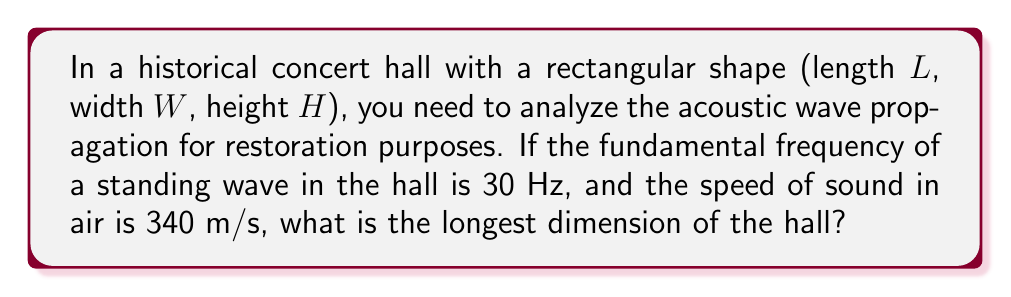Solve this math problem. To solve this problem, we'll follow these steps:

1) The fundamental frequency of a standing wave in a rectangular room is given by:

   $$f = \frac{c}{2} \sqrt{\left(\frac{n_x}{L}\right)^2 + \left(\frac{n_y}{W}\right)^2 + \left(\frac{n_z}{H}\right)^2}$$

   where $c$ is the speed of sound, and $n_x$, $n_y$, and $n_z$ are integers.

2) For the fundamental frequency, $n_x = 1$, $n_y = 0$, and $n_z = 0$ (assuming $L$ is the longest dimension).

3) Substituting these values:

   $$30 = \frac{340}{2} \sqrt{\left(\frac{1}{L}\right)^2 + 0 + 0}$$

4) Simplify:

   $$30 = \frac{340}{2L}$$

5) Solve for $L$:

   $$L = \frac{340}{2 \cdot 30} = \frac{340}{60} = \frac{17}{3} \approx 5.67$$

Therefore, the longest dimension of the hall is approximately 5.67 meters.
Answer: $\frac{17}{3}$ m or approximately 5.67 m 